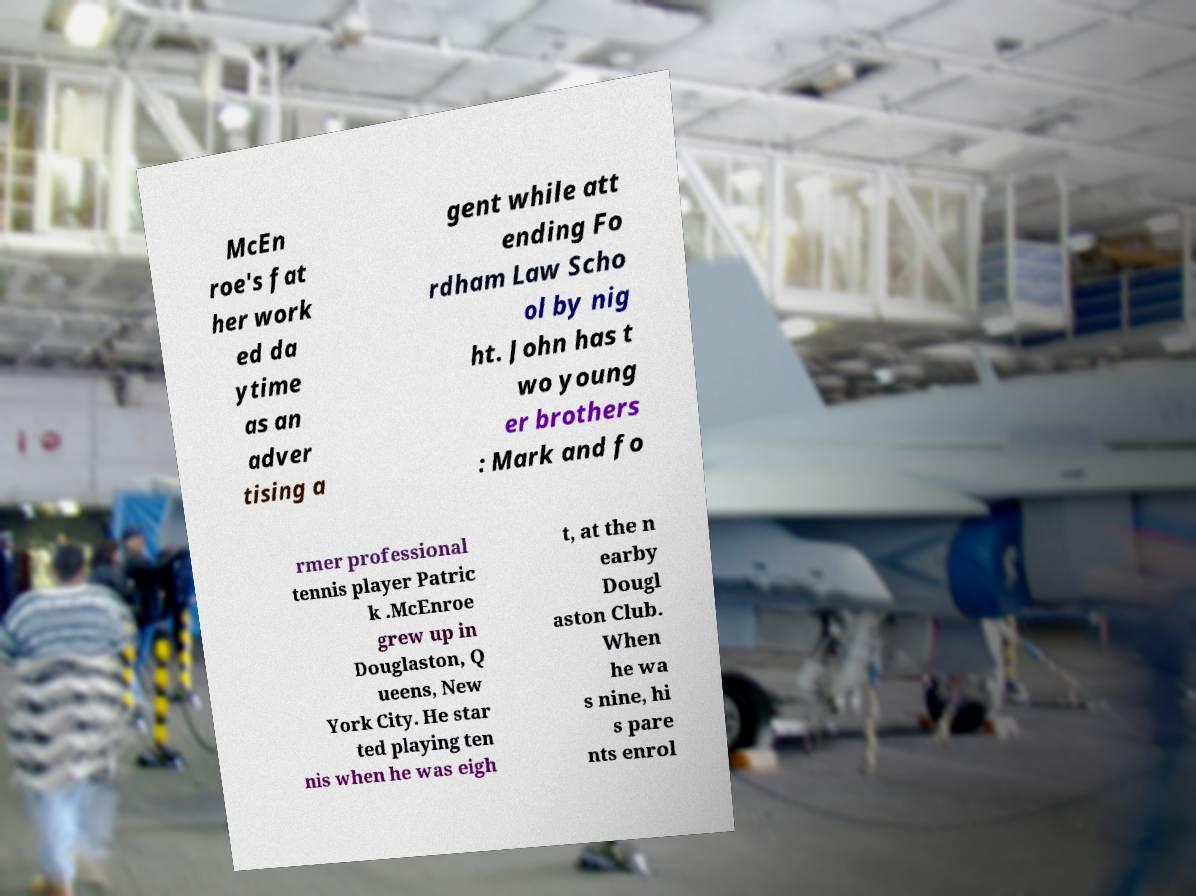Can you accurately transcribe the text from the provided image for me? McEn roe's fat her work ed da ytime as an adver tising a gent while att ending Fo rdham Law Scho ol by nig ht. John has t wo young er brothers : Mark and fo rmer professional tennis player Patric k .McEnroe grew up in Douglaston, Q ueens, New York City. He star ted playing ten nis when he was eigh t, at the n earby Dougl aston Club. When he wa s nine, hi s pare nts enrol 